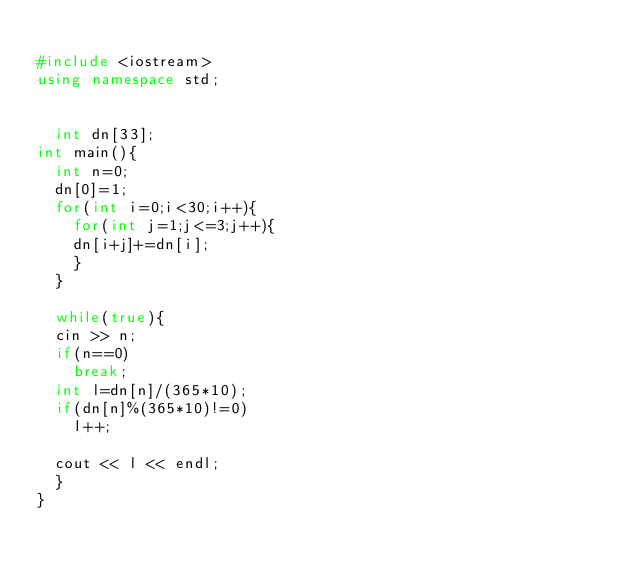<code> <loc_0><loc_0><loc_500><loc_500><_C++_>
#include <iostream>
using namespace std;

	
	int dn[33];
int main(){
	int n=0;
	dn[0]=1;
	for(int i=0;i<30;i++){
		for(int j=1;j<=3;j++){
		dn[i+j]+=dn[i];
		}
	}
	
	while(true){
	cin >> n;
	if(n==0)
		break;
	int l=dn[n]/(365*10);
	if(dn[n]%(365*10)!=0)
		l++;

	cout << l << endl;
	}
}</code> 